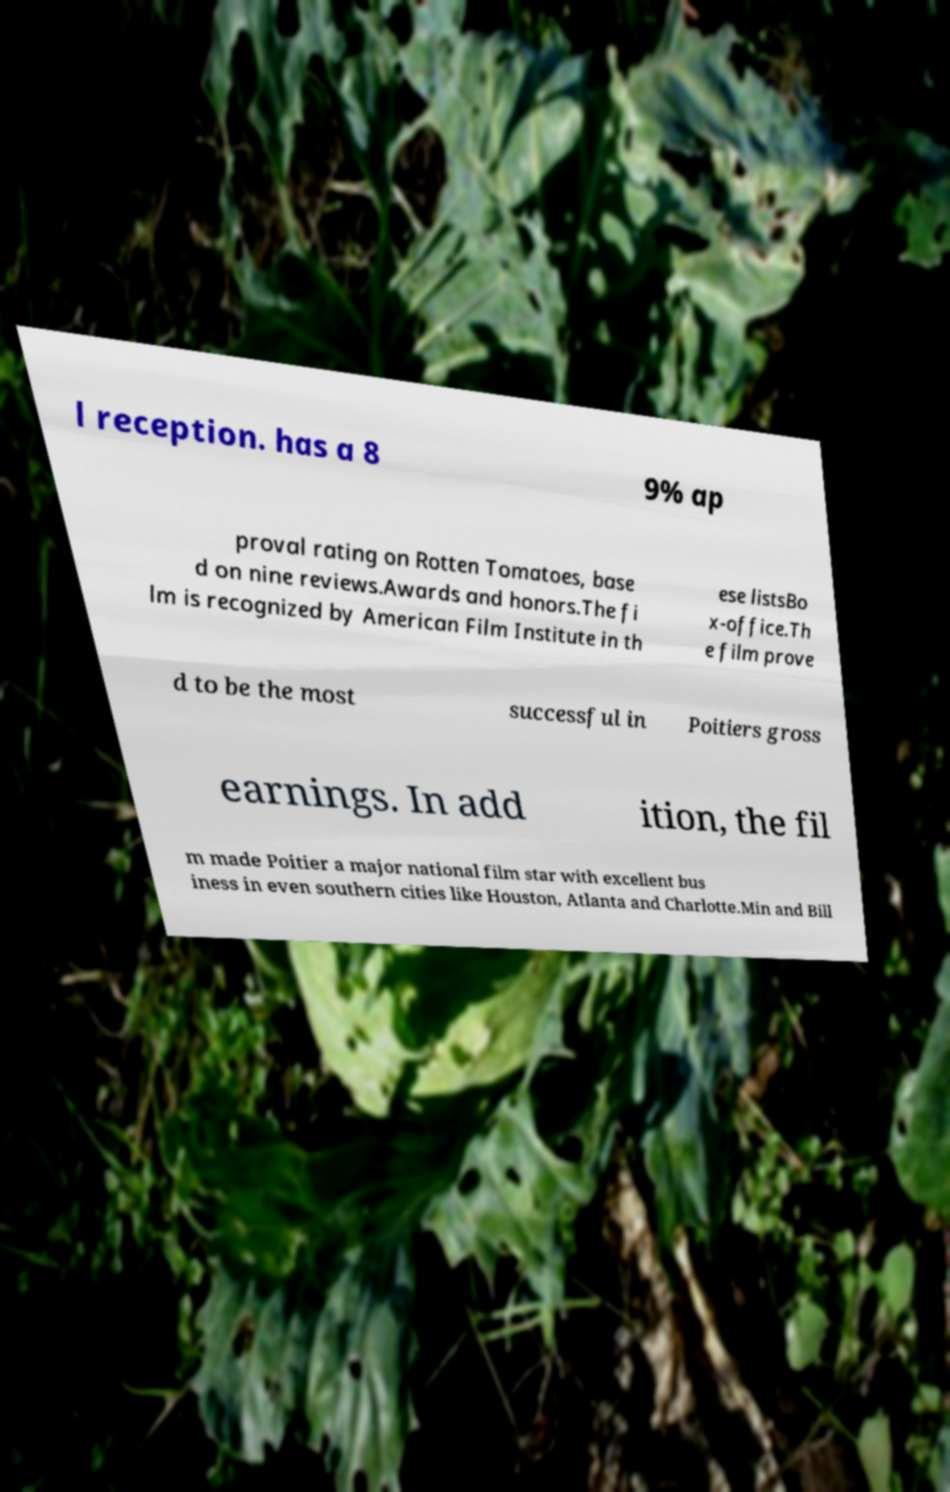Could you extract and type out the text from this image? l reception. has a 8 9% ap proval rating on Rotten Tomatoes, base d on nine reviews.Awards and honors.The fi lm is recognized by American Film Institute in th ese listsBo x-office.Th e film prove d to be the most successful in Poitiers gross earnings. In add ition, the fil m made Poitier a major national film star with excellent bus iness in even southern cities like Houston, Atlanta and Charlotte.Min and Bill 